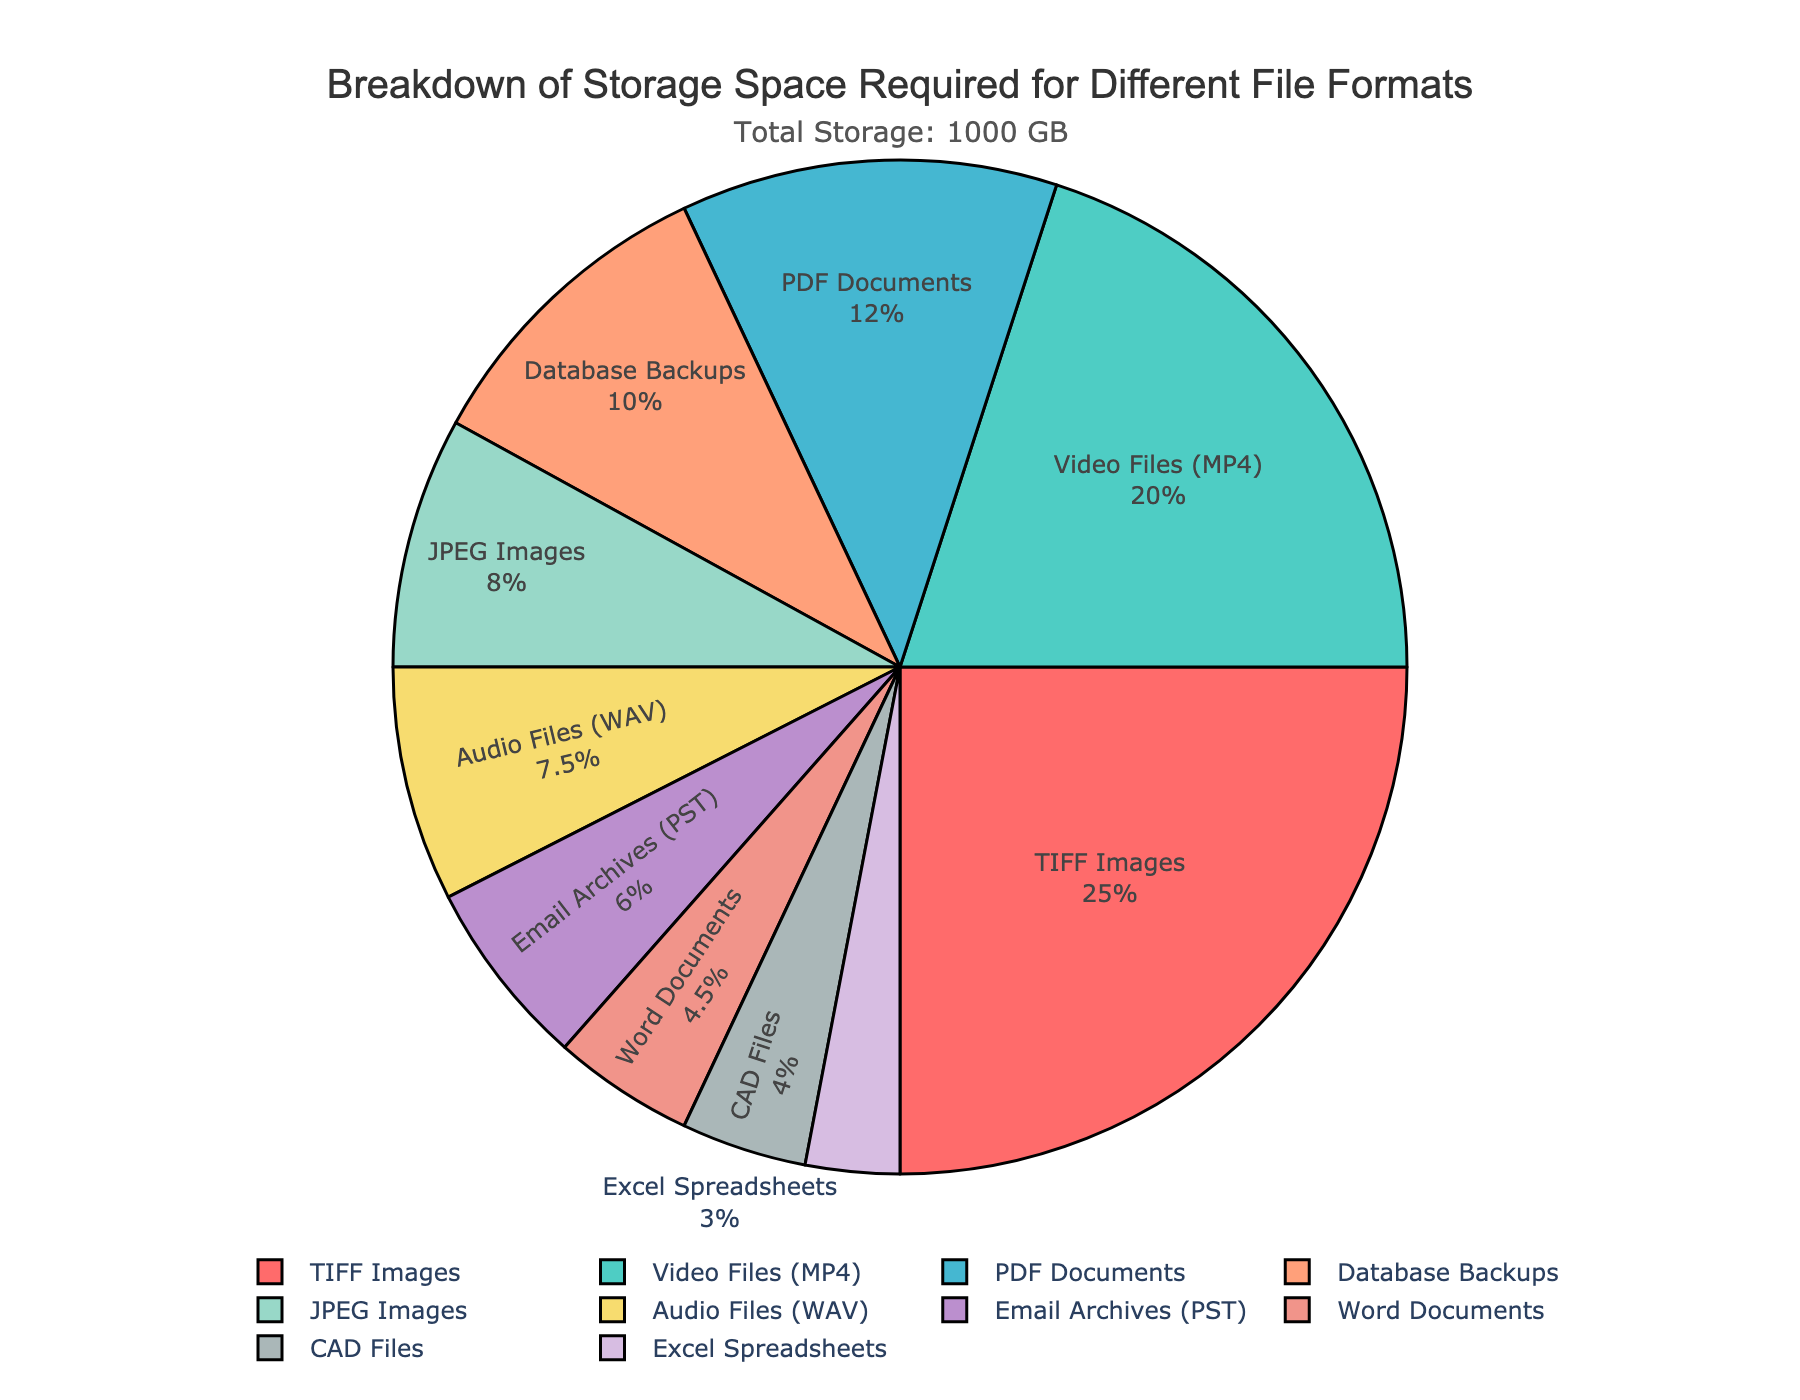what percentage of storage space is consumed by TIFF and MP4 files combined? First, refer to the pie chart to find the percentage of storage space each file type occupies. For TIFF Images, it's 29.41%, and for Video Files (MP4), it's 23.53%. Combining these, we get 29.41 + 23.53 = 52.94%.
Answer: 52.94% What file type consumes the least amount of storage space? Refer to the pie chart to identify the smallest segment. Excel Spreadsheets consume the least storage space with 3.53% of the total storage.
Answer: Excel Spreadsheets Which file type has a larger storage requirement: database backups or email archives? Refer to the pie chart to compare the size of segments for Database Backups and Email Archives. Database Backups occupy 11.76% of the storage, while Email Archives occupy 7.06%.
Answer: Database Backups How much more storage space do TIFF Images require compared to Audio Files (WAV)? Refer to the pie chart to find the storage space each file type occupies. TIFF Images require 250 GB, and Audio Files (WAV) require 75 GB. The difference is 250 - 75 = 175 GB.
Answer: 175 GB Is the storage requirement for JPEG Images greater than that for Word Documents and Excel Spreadsheets combined? Find the storage space required for JPEG Images, Word Documents, and Excel Spreadsheets in the pie chart. JPEG Images occupy 9.41% of the storage, whereas Word Documents and Excel Spreadsheets combined occupy 5.29% + 3.53% = 8.82%. Since 9.41% > 8.82%, JPEG Images have a greater storage requirement.
Answer: Yes Which file types have storage requirements closest to each other? By referring to the pie chart, compare the segments and find pairs with close percentages. Word Documents (5.29%) and CAD Files (4.71%) have storage requirements that are close to each other.
Answer: Word Documents and CAD Files Calculate the average storage space consumed by PDF Documents, Word Documents, and CAD Files. Find the storage space for each of the three file types:
PDF Documents = 120 GB, Word Documents = 45 GB, CAD Files = 40 GB. Sum these up: 120 + 45 + 40 = 205 GB. Then, divide by 3: 205 / 3 = 68.33 GB.
Answer: 68.33 GB What is the total storage space required for file types that use less than 100 GB each? Identify the file types with less than 100 GB storage:
JPEG Images (80 GB), Word Documents (45 GB), Excel Spreadsheets (30 GB), Audio Files (WAV) (75 GB), CAD Files (40 GB), and Email Archives (60 GB). Sum these up: 80 + 45 + 30 + 75 + 40 + 60 = 330 GB.
Answer: 330 GB 